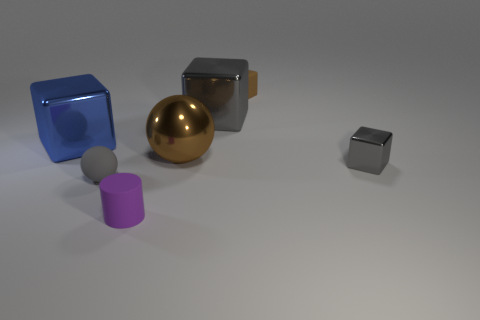There is a block that is made of the same material as the gray sphere; what is its color?
Your answer should be compact. Brown. There is a small thing that is on the right side of the small brown matte cube; how many tiny purple things are behind it?
Provide a short and direct response. 0. There is a tiny thing that is both in front of the small brown rubber cube and on the right side of the big brown thing; what is its material?
Your answer should be compact. Metal. There is a big brown thing behind the tiny gray rubber sphere; is its shape the same as the tiny brown matte object?
Provide a short and direct response. No. Are there fewer gray metal objects than tiny red things?
Your answer should be very brief. No. What number of matte objects are the same color as the tiny sphere?
Your response must be concise. 0. There is a tiny block that is the same color as the large sphere; what is it made of?
Your answer should be compact. Rubber. There is a small ball; does it have the same color as the big cube that is on the right side of the tiny cylinder?
Your response must be concise. Yes. Are there more tiny brown cubes than gray rubber cubes?
Offer a very short reply. Yes. What is the size of the blue metal thing that is the same shape as the brown matte object?
Offer a very short reply. Large. 